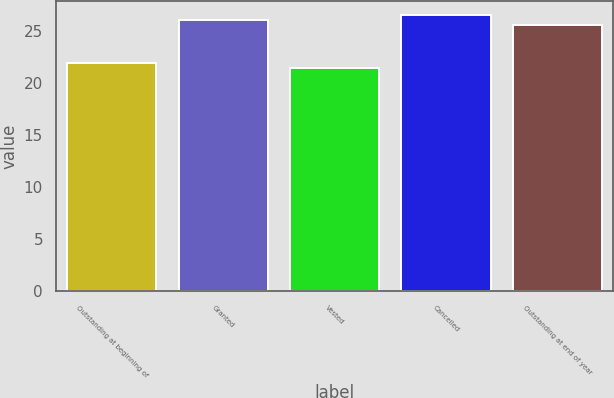Convert chart. <chart><loc_0><loc_0><loc_500><loc_500><bar_chart><fcel>Outstanding at beginning of<fcel>Granted<fcel>Vested<fcel>Cancelled<fcel>Outstanding at end of year<nl><fcel>21.94<fcel>26.06<fcel>21.48<fcel>26.52<fcel>25.6<nl></chart> 